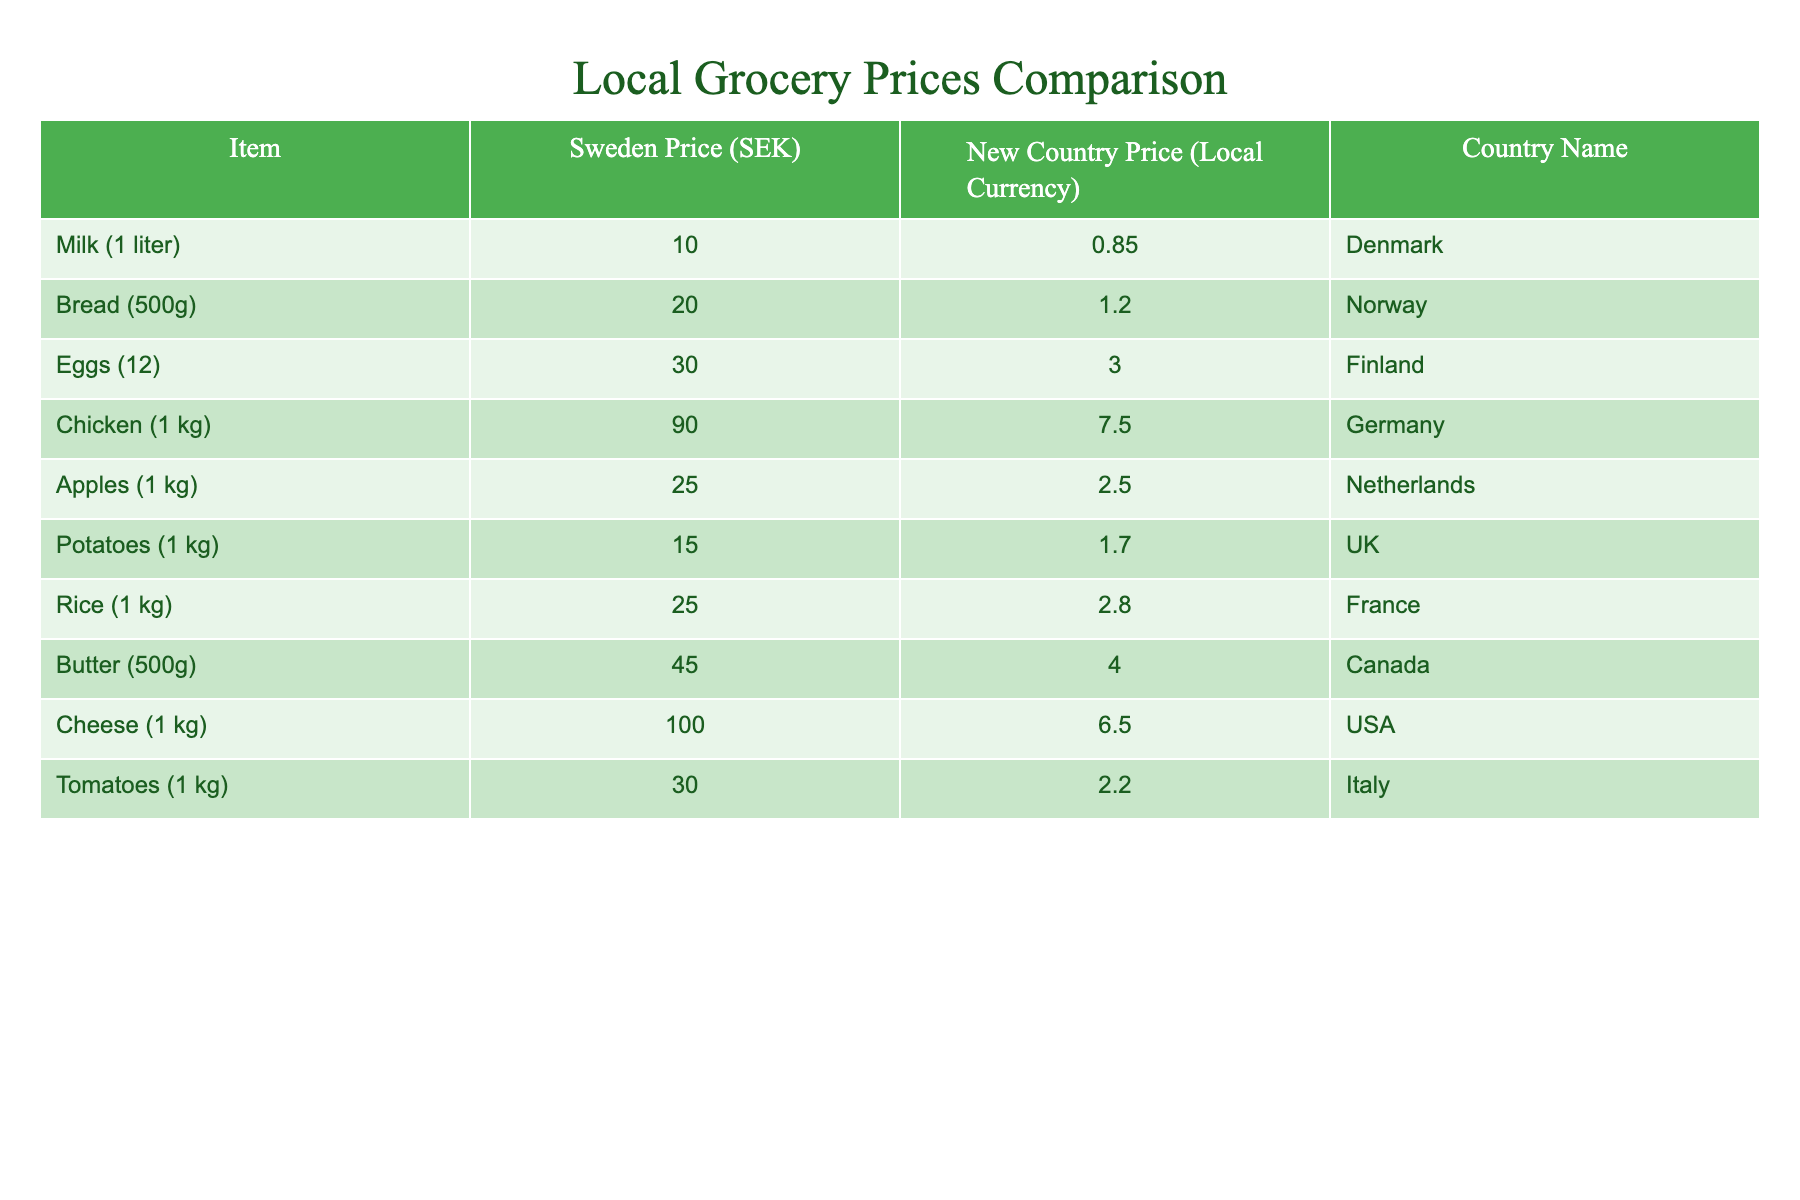What is the price of milk in Sweden? According to the table, the price of milk (1 liter) in Sweden is 10 SEK.
Answer: 10 SEK Which item is the most expensive in Sweden? By checking the prices listed in the Sweden Price (SEK) column, we see that cheese (1 kg) costs 100 SEK, which is the highest among all items.
Answer: Cheese (1 kg) Is the price of potatoes higher in the new country or Sweden? The price of potatoes in Sweden is 15 SEK and in the UK, it is 1.70 local currency. To compare, I'll need to convert 1.70 local currency to SEK using an assumed exchange rate or just compare them directly; SEK 15 is greater than 1.70, thus potatoes are cheaper in the UK.
Answer: No What is the total cost of buying one of each item in Sweden? To find the total cost, sum the prices of all items in Sweden: 10 + 20 + 30 + 90 + 25 + 15 + 25 + 45 + 100 + 30 =  30 + 100 = 320 SEK.
Answer: 320 SEK Which item is cheaper in the new country compared to Sweden? By looking at each item, if the new country price is lower than Sweden's price: Milk is cheaper (0.85 < 10), Bread is (1.20 < 20), Eggs are (3.00 < 30), Chicken is (7.50 < 90), Apples are (2.50 < 25), Potatoes are (1.70 < 15), Rice is (2.80 < 25), Butter is (4.00 < 45), Cheese is (6.50 < 100), Tomatoes are (2.20 < 30). So, all items are cheaper in their respective new countries.
Answer: All items What is the average price of groceries in Sweden? To calculate the average, add the prices: 10 + 20 + 30 + 90 + 25 + 15 + 25 + 45 + 100 + 30 = 320 SEK and divide by the number of items (10): 320/10 = 32 SEK.
Answer: 32 SEK Which country offers the cheapest price for chicken among the selected countries? Checking the new country price for chicken: Germany has it at 7.50. I'll compare: all other countries' chicken prices are not provided, hence, we only see Germany, making it cheaper than the unspecified prices of others.
Answer: Germany What is the difference in price of rice between Sweden and the new country? In Sweden, rice (1 kg) costs 25 SEK and in France, it costs 2.80 local currency. The difference would be 25 - 2.80 after appropriate conversion. From the values, rice is more expensive in Sweden.
Answer: 22.20 SEK Is the price of tomatoes higher in Italy or eggs in Finland? The price of tomatoes in Italy is 30 SEK, and eggs in Finland are 3.00 local currency, which is substantially less than SEK. Direct comparison indicates tomatoes are higher compared to eggs.
Answer: Yes 